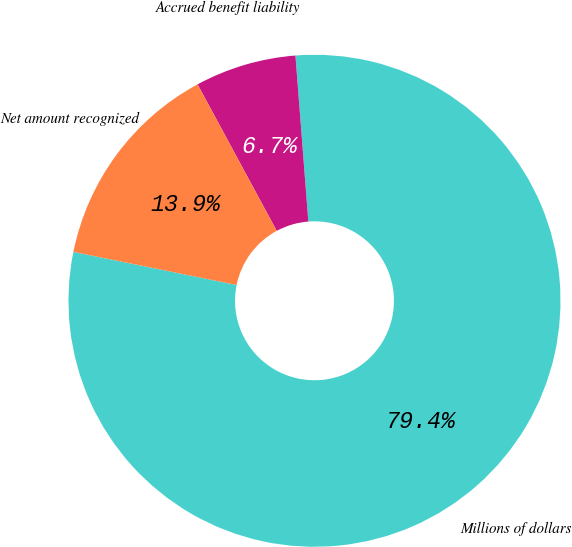Convert chart to OTSL. <chart><loc_0><loc_0><loc_500><loc_500><pie_chart><fcel>Millions of dollars<fcel>Accrued benefit liability<fcel>Net amount recognized<nl><fcel>79.42%<fcel>6.65%<fcel>13.93%<nl></chart> 